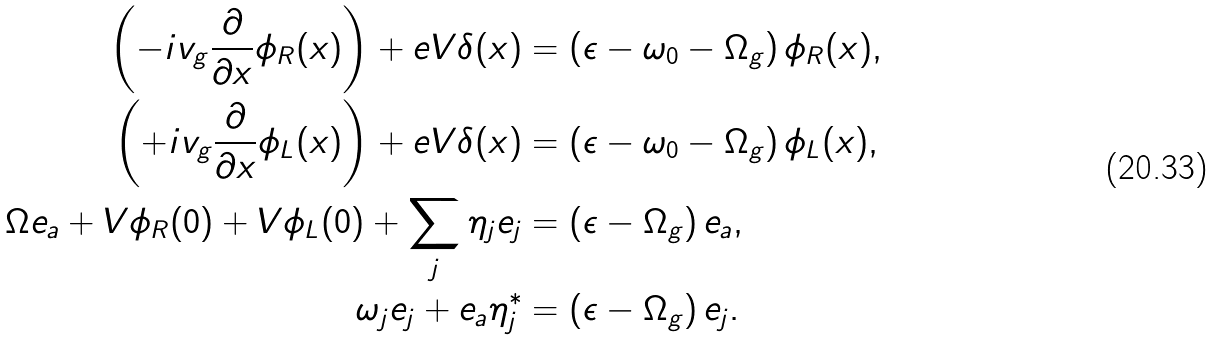<formula> <loc_0><loc_0><loc_500><loc_500>\left ( - i v _ { g } \frac { \partial } { \partial x } \phi _ { R } ( x ) \right ) + e V \delta ( x ) & = \left ( \epsilon - \omega _ { 0 } - \Omega _ { g } \right ) \phi _ { R } ( x ) , \\ \left ( + i v _ { g } \frac { \partial } { \partial x } \phi _ { L } ( x ) \right ) + e V \delta ( x ) & = \left ( \epsilon - \omega _ { 0 } - \Omega _ { g } \right ) \phi _ { L } ( x ) , \\ \Omega e _ { a } + V \phi _ { R } ( 0 ) + V \phi _ { L } ( 0 ) + \sum _ { j } \eta _ { j } e _ { j } & = \left ( \epsilon - \Omega _ { g } \right ) e _ { a } , \\ \omega _ { j } e _ { j } + e _ { a } \eta _ { j } ^ { * } & = \left ( \epsilon - \Omega _ { g } \right ) e _ { j } .</formula> 